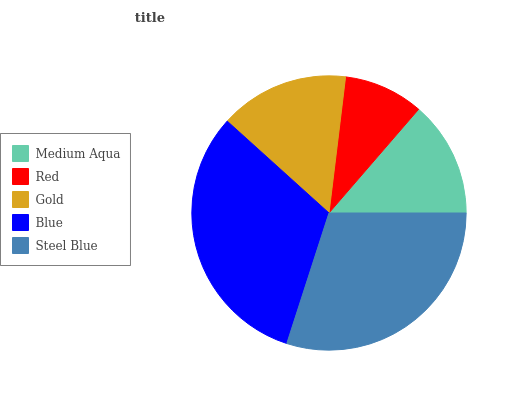Is Red the minimum?
Answer yes or no. Yes. Is Blue the maximum?
Answer yes or no. Yes. Is Gold the minimum?
Answer yes or no. No. Is Gold the maximum?
Answer yes or no. No. Is Gold greater than Red?
Answer yes or no. Yes. Is Red less than Gold?
Answer yes or no. Yes. Is Red greater than Gold?
Answer yes or no. No. Is Gold less than Red?
Answer yes or no. No. Is Gold the high median?
Answer yes or no. Yes. Is Gold the low median?
Answer yes or no. Yes. Is Red the high median?
Answer yes or no. No. Is Medium Aqua the low median?
Answer yes or no. No. 